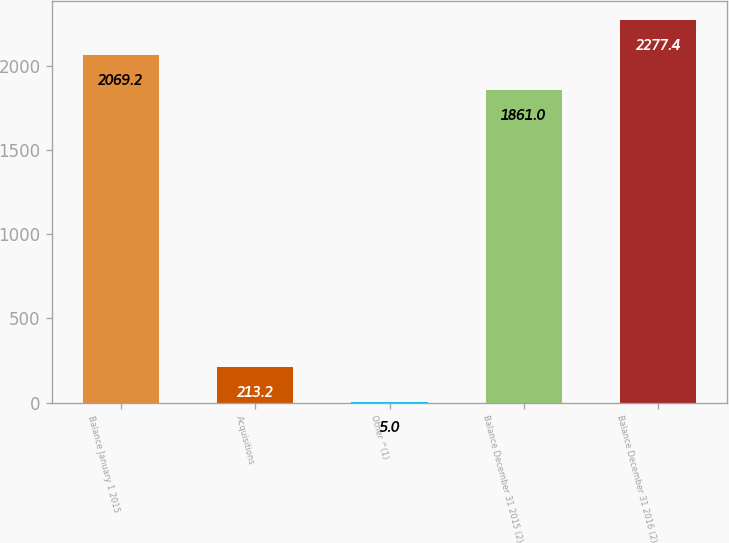Convert chart. <chart><loc_0><loc_0><loc_500><loc_500><bar_chart><fcel>Balance January 1 2015<fcel>Acquisitions<fcel>Other ^(1)<fcel>Balance December 31 2015 (2)<fcel>Balance December 31 2016 (2)<nl><fcel>2069.2<fcel>213.2<fcel>5<fcel>1861<fcel>2277.4<nl></chart> 